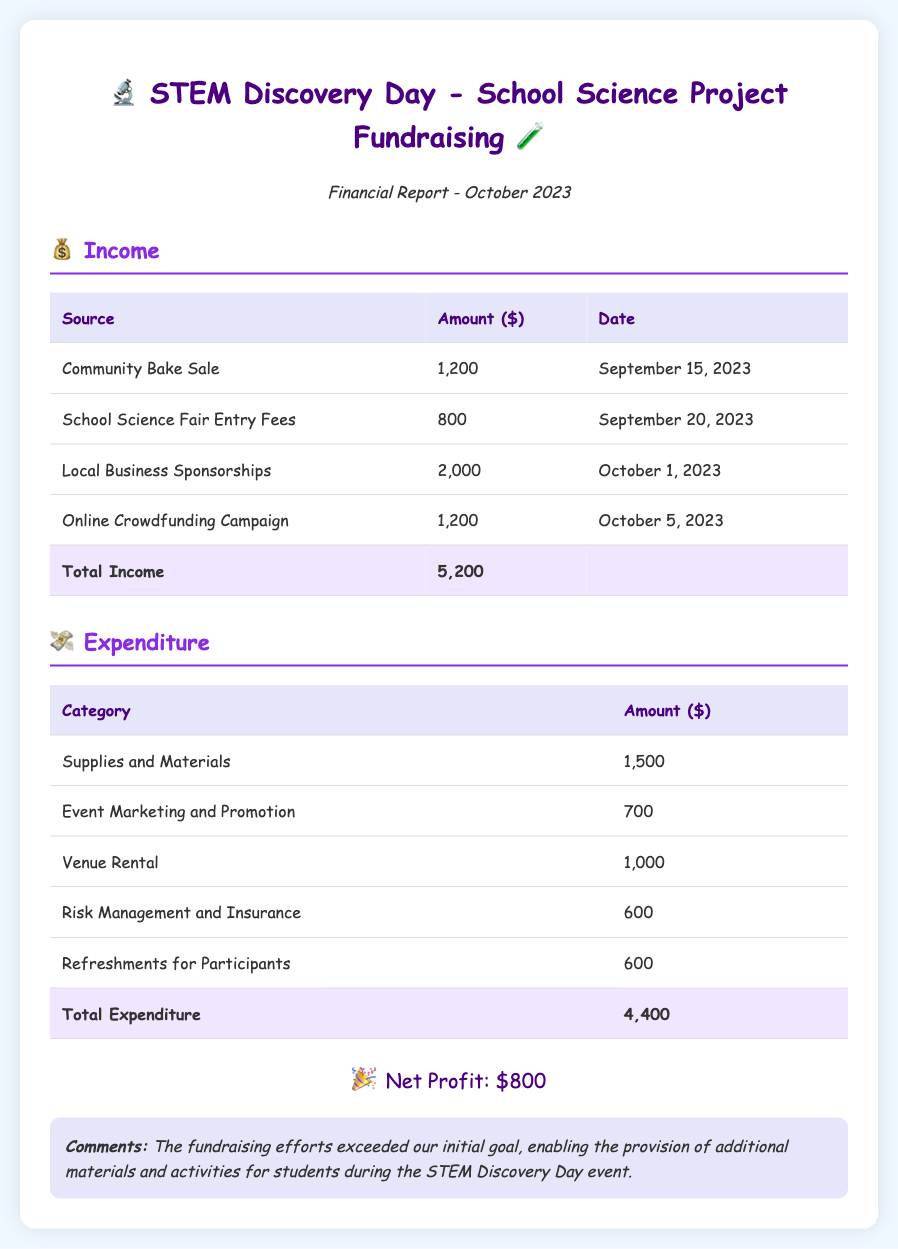what is the total income? The total income is the sum of all income sources in the document: 1200 + 800 + 2000 + 1200 = 5200.
Answer: 5200 what is the date of the financial report? The date of the financial report is indicated at the top of the document.
Answer: October 2023 how much was raised from the community bake sale? The amount raised from the community bake sale can be found in the income section of the report.
Answer: 1200 what is the total expenditure? The total expenditure is the sum of all expenditure categories: 1500 + 700 + 1000 + 600 + 600 = 4400.
Answer: 4400 what is the net profit from the fundraising? The net profit is calculated by subtracting total expenditure from total income.
Answer: 800 how much was spent on venue rental? The amount spent on venue rental is specified under the expenditure section.
Answer: 1000 which source generated the highest income? The source of income with the highest amount is listed in the income section.
Answer: Local Business Sponsorships how much was allocated for supplies and materials? The amount allocated for supplies and materials can be found under the expenditure section.
Answer: 1500 what is the purpose of the comments in the report? The comments section provides additional insights regarding the success of the fundraising efforts.
Answer: Additional materials and activities for students 